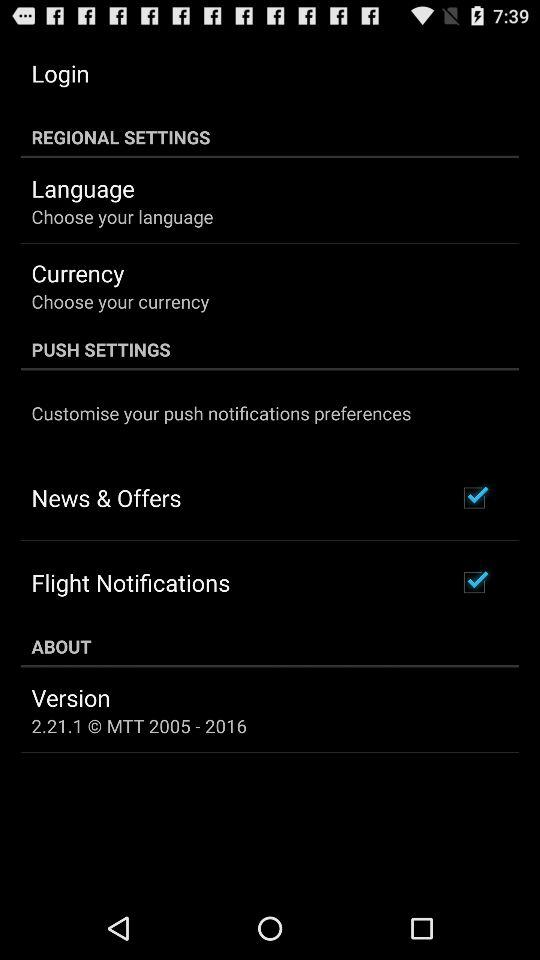How many checkbox items are there in the Push Settings section?
Answer the question using a single word or phrase. 2 